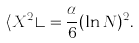<formula> <loc_0><loc_0><loc_500><loc_500>\langle X ^ { 2 } \rangle = \frac { \alpha } { 6 } ( \ln N ) ^ { 2 } .</formula> 